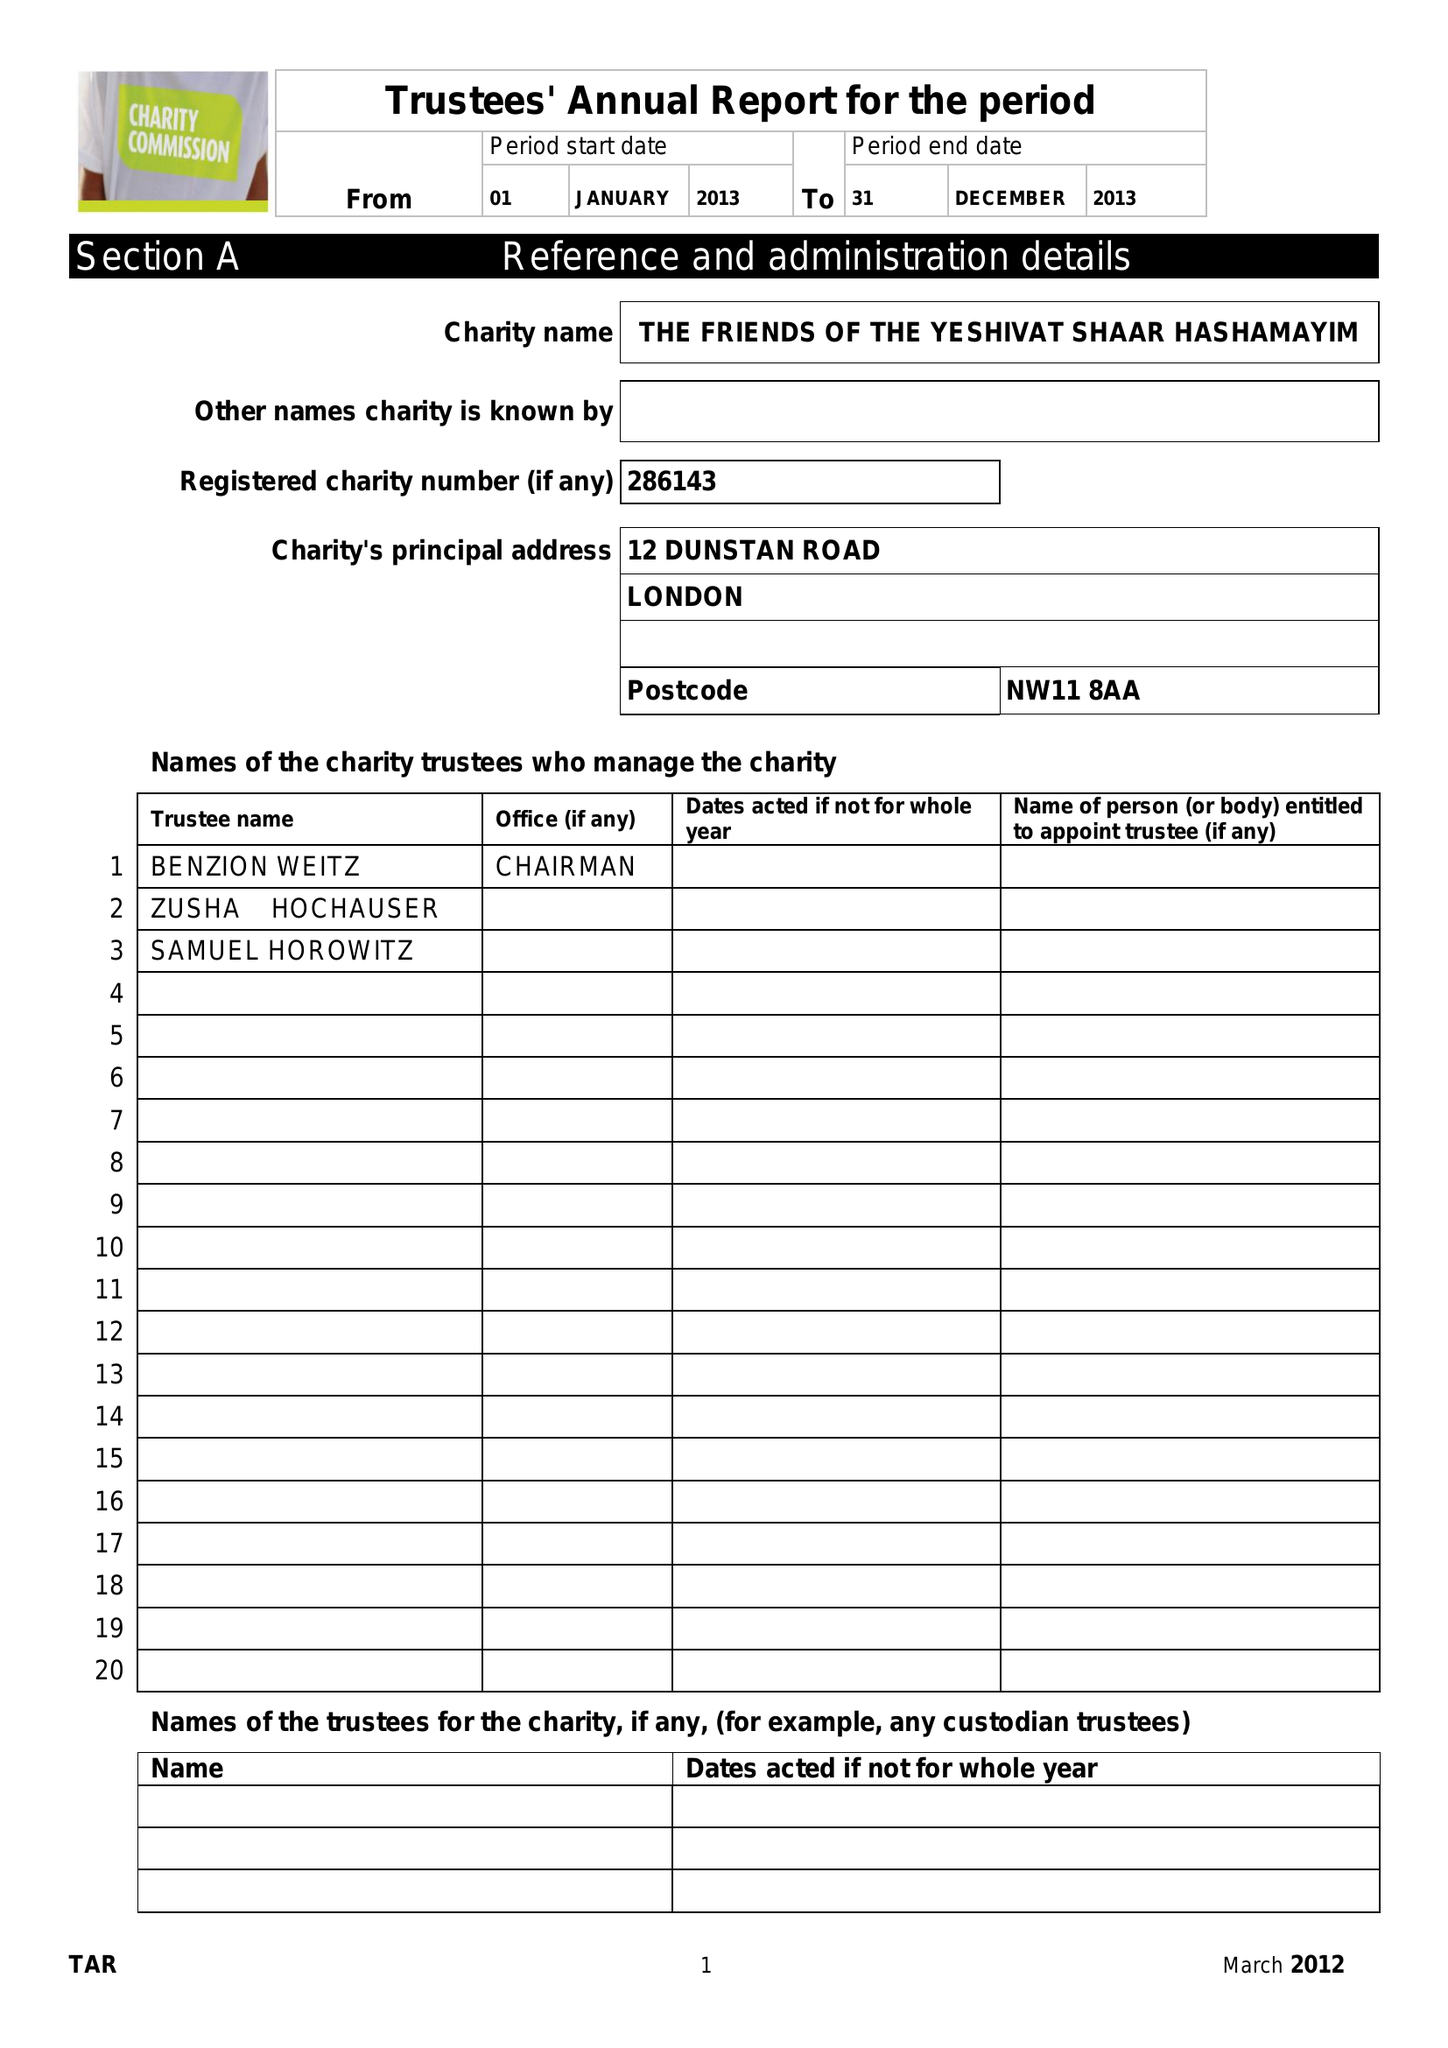What is the value for the charity_name?
Answer the question using a single word or phrase. The Friends Of The Yeshivat Shaar Hashamayim 